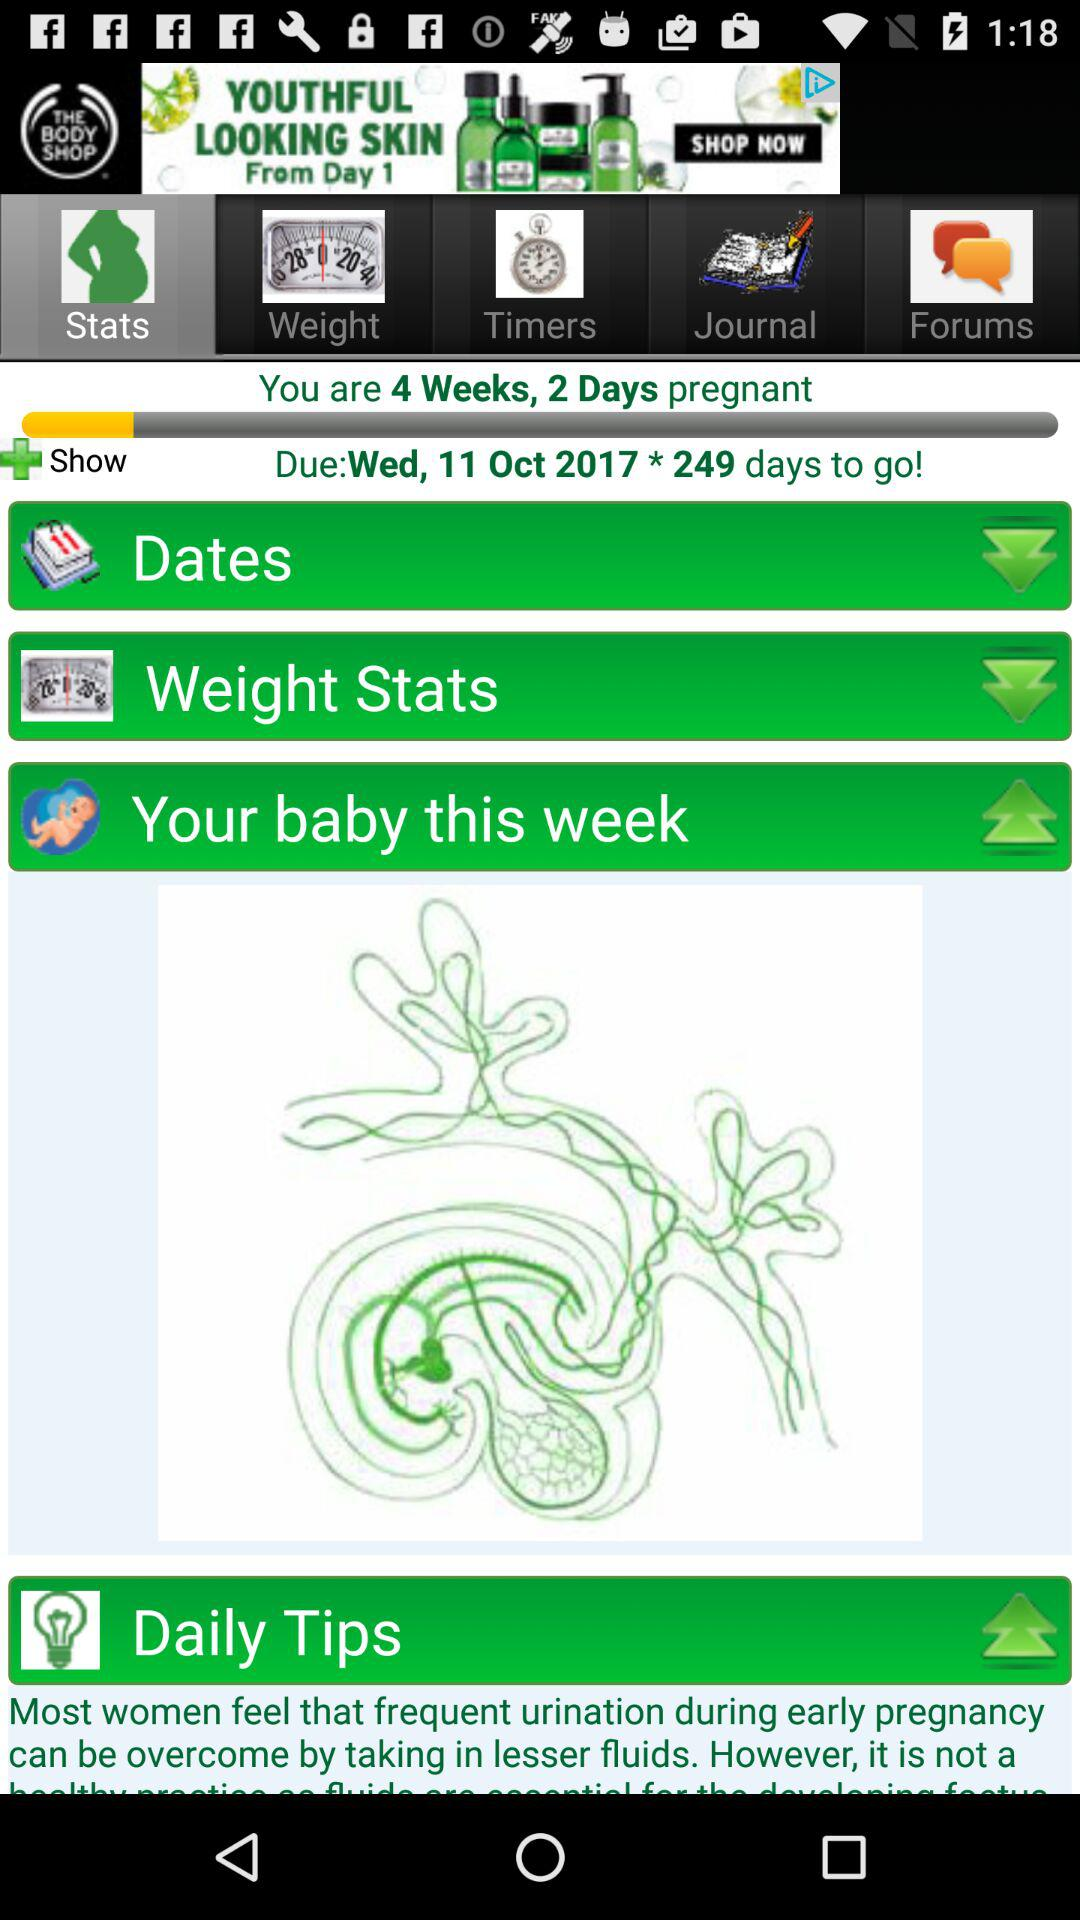How many days are left until the due date?
Answer the question using a single word or phrase. 249 